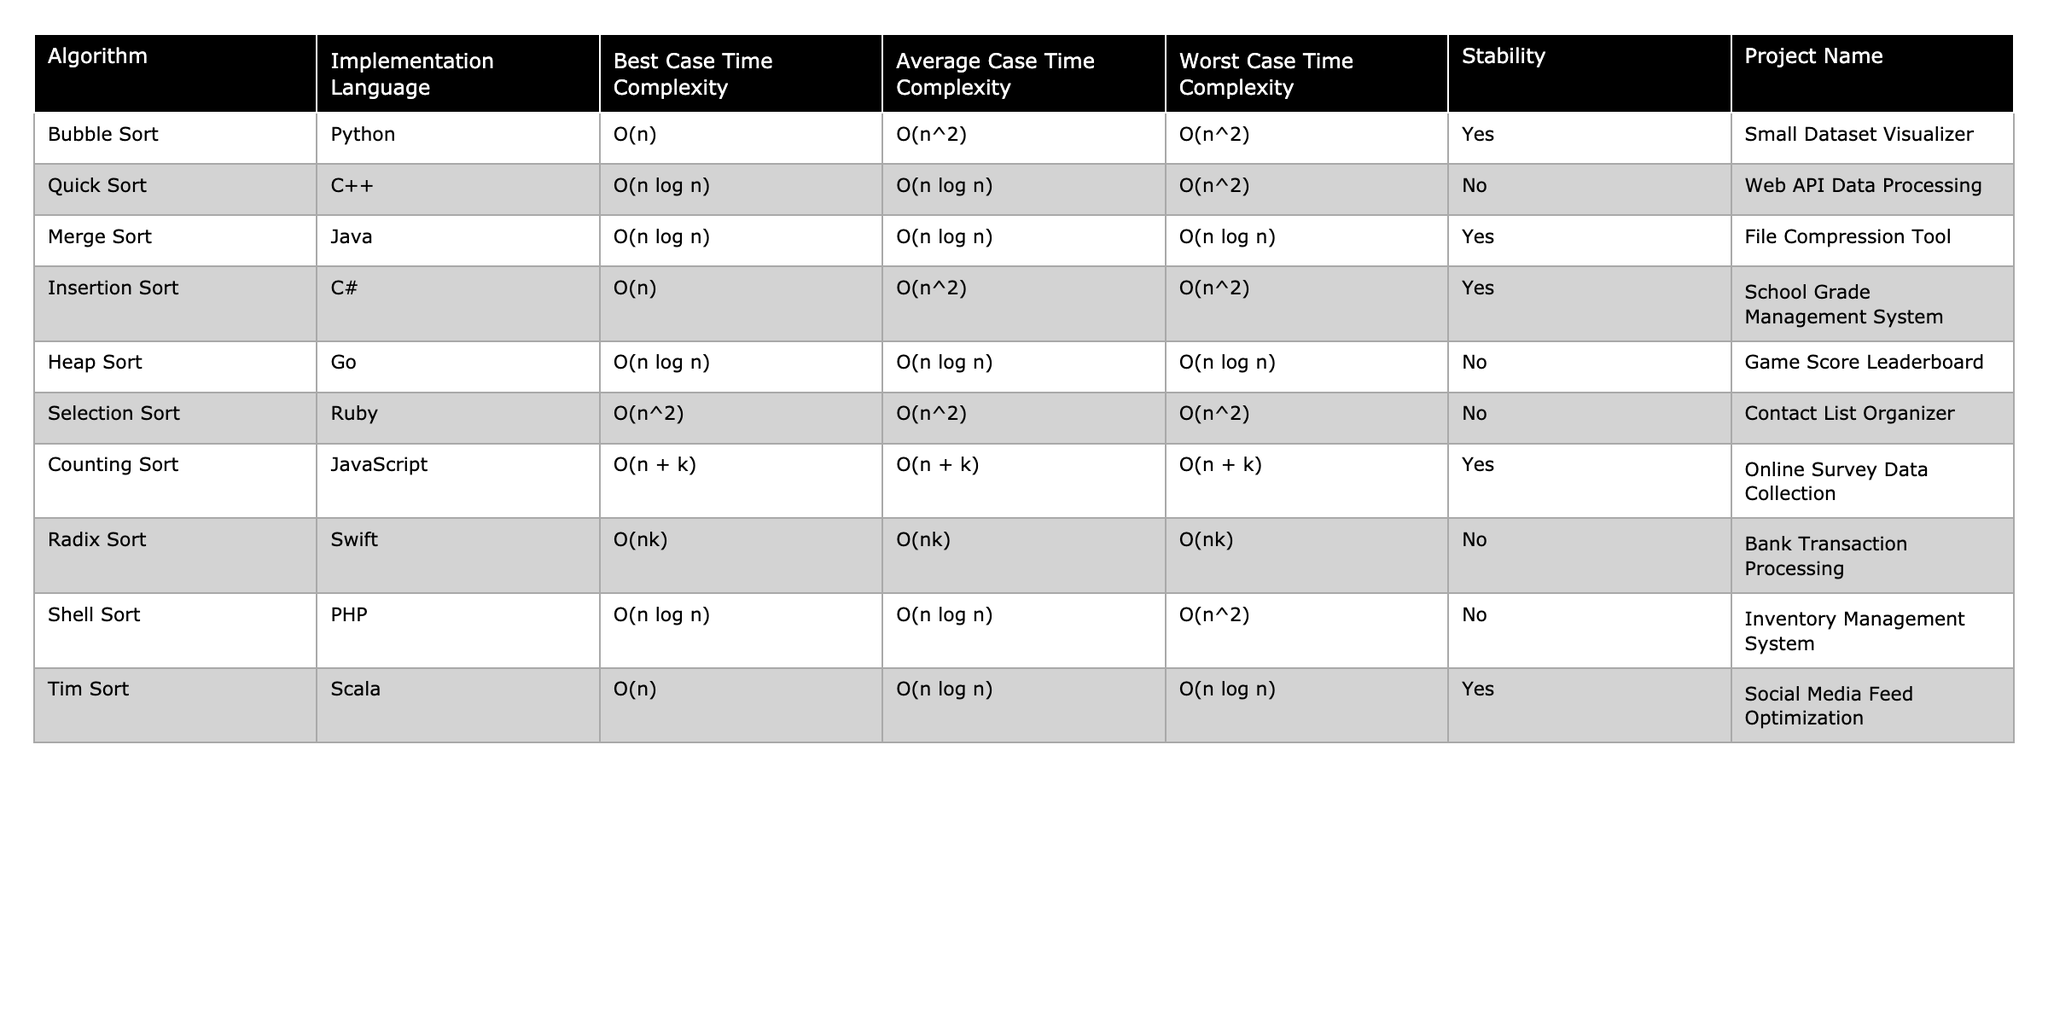What is the worst-case time complexity of Quick Sort? The table lists the worst-case time complexity for Quick Sort as O(n^2).
Answer: O(n^2) Which sorting algorithm is stable and has the best case time complexity of O(n)? Looking at the table, the algorithms that are stable and have a best case time complexity of O(n) are Bubble Sort (Python) and Insertion Sort (C#).
Answer: Bubble Sort and Insertion Sort How many algorithms have a worst-case time complexity of O(n log n)? By checking the table, the algorithms with a worst-case time complexity of O(n log n) are Quick Sort, Merge Sort, Heap Sort, Shell Sort, and Tim Sort. There are five such algorithms.
Answer: 5 Is Insertion Sort a stable sorting algorithm? The table indicates that Insertion Sort is indeed a stable sorting algorithm (marked as "Yes").
Answer: Yes What is the average time complexity of Counting Sort? According to the table, the average time complexity of Counting Sort is O(n + k).
Answer: O(n + k) Which implementation language is used for Tim Sort, and is it stable? The table shows that Tim Sort is implemented in Scala and it is marked as stable (Yes).
Answer: Scala, Yes How do the average case time complexities of Bubble Sort and Selection Sort compare? The average case time complexity of Bubble Sort is O(n^2) and for Selection Sort it’s also O(n^2). Therefore, they are equal.
Answer: They are equal What is the time complexity of Radix Sort in the worst-case scenario? The table shows that the worst-case time complexity of Radix Sort is O(nk).
Answer: O(nk) Are there more sorting algorithms that are unstable than stable in the provided data? From the table, the unstable algorithms are Quick Sort, Heap Sort, Selection Sort, and Radix Sort (4 algorithms), while the stable ones are Bubble Sort, Merge Sort, Counting Sort, Insertion Sort, Tim Sort (5 algorithms). Since 5 > 4, there are more stable algorithms.
Answer: No What is the only sorting algorithm in this table that has a best-case time complexity of O(nk), and is it stable? According to the table, Radix Sort is the only algorithm with a best-case time complexity of O(nk), and it is marked as unstable (No).
Answer: Radix Sort, No 